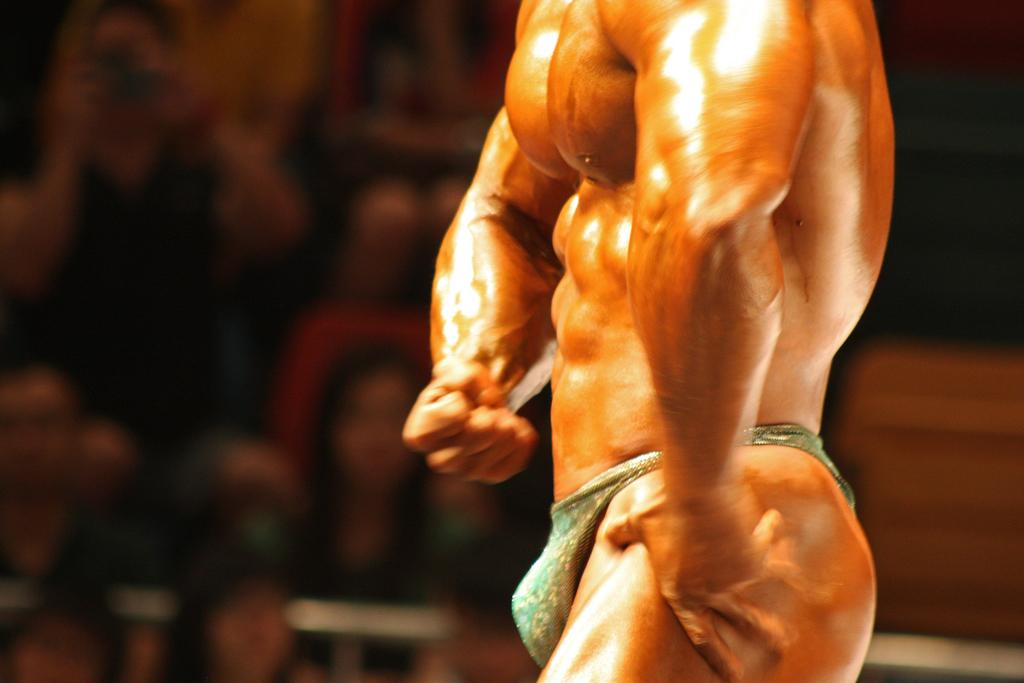What is the main subject in the foreground of the image? There is a bodybuilder in the foreground of the image. Can you describe the background of the image? The background of the image is blurry. What type of teeth does the worm have in the image? There is no worm present in the image, so it is not possible to determine what type of teeth it might have. 